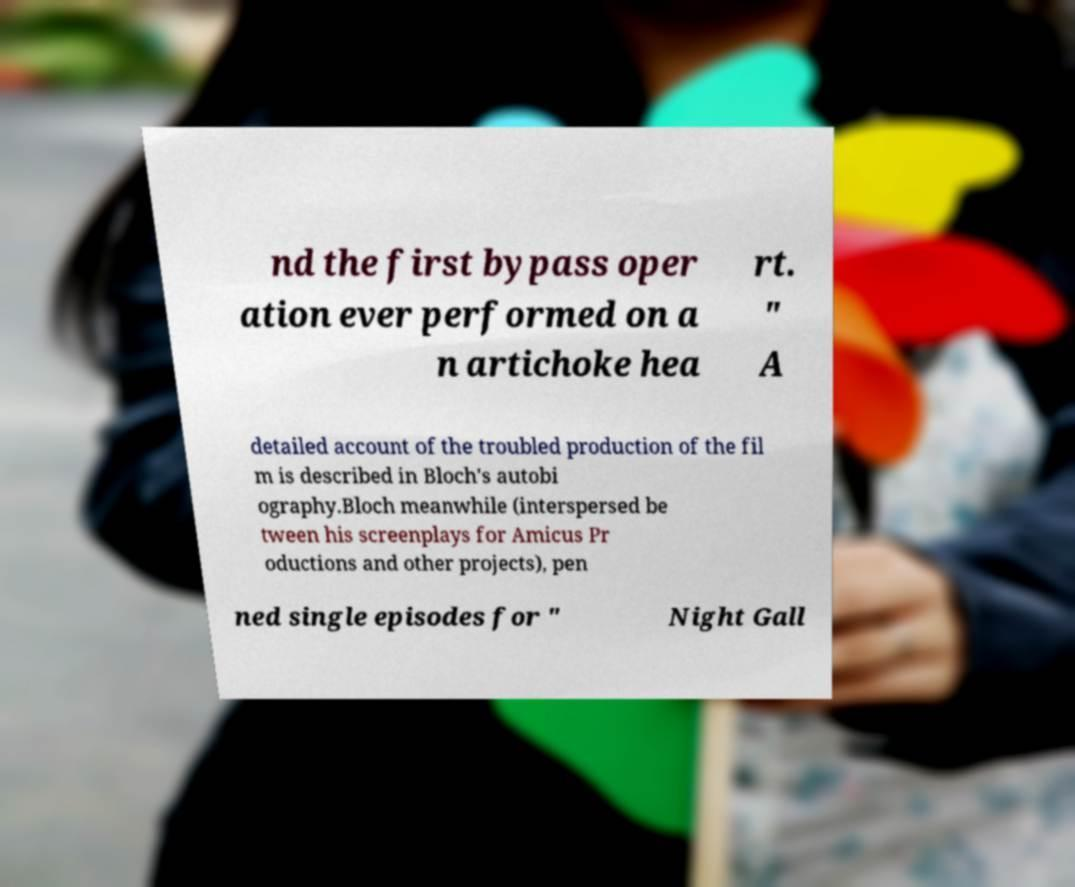For documentation purposes, I need the text within this image transcribed. Could you provide that? nd the first bypass oper ation ever performed on a n artichoke hea rt. " A detailed account of the troubled production of the fil m is described in Bloch's autobi ography.Bloch meanwhile (interspersed be tween his screenplays for Amicus Pr oductions and other projects), pen ned single episodes for " Night Gall 